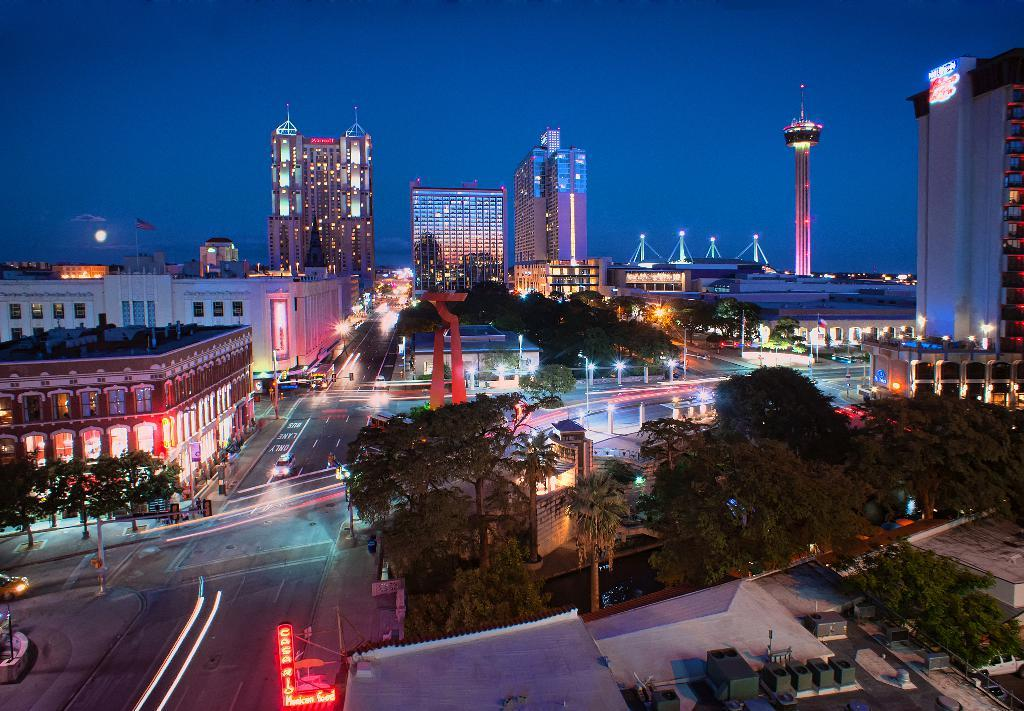What type of view is provided in the image? The image is a top view of a city. What natural elements can be seen in the image? There are trees visible in the image. What man-made structures are present in the image? Vehicles are present on the roads, and buildings with sign boards are visible in the image. What letter is being used by the army in the image? There is no army or letter present in the image. 